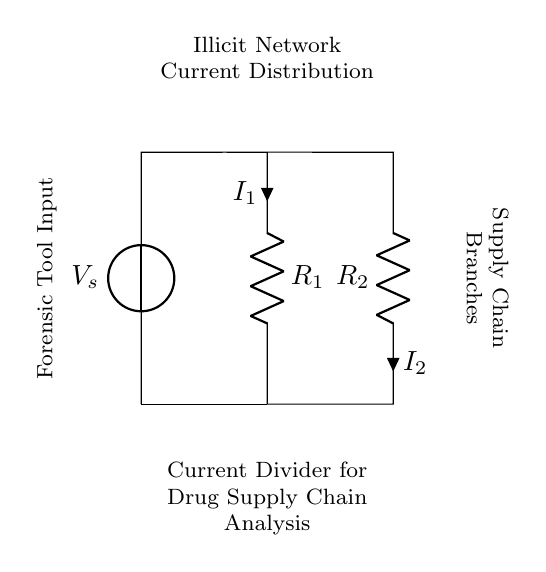What is the source voltage of this circuit? The voltage source is labeled as V_s, which represents the input voltage for the circuit, visible at the top of the circuit diagram.
Answer: V_s What are the two resistors in this current divider? The resistors in the current divider are labeled R_1 and R_2, which can be identified from the circuit as the components through which the current divides.
Answer: R_1, R_2 How many branches does the current split into? The current splits into two branches, corresponding to the two resistors in the current divider configuration. This can be determined by observing the paths the current takes through R_1 and R_2.
Answer: 2 What type of analysis does this current divider model represent? The diagram indicates that this current divider is used for drug supply chain analysis, specifically tracing illicit networks as noted at the bottom of the circuit.
Answer: Drug Supply Chain Analysis What is the current through resistor R_1 indicated as? The current through resistor R_1 is labeled as I_1, shown at the lower side of the resistor in the circuit diagram, indicating the flow of current through that branch.
Answer: I_1 Why is the connection labeled "Forensic Tool Input" important? This label highlights where the input for the forensic analysis tool is applied in the circuit, establishing the importance of how the analysis tool interfaces with the current divider to trace drug supply chains.
Answer: Important for analysis input What does the current flow direction through R_2 imply? The current flow direction through R_2 is indicated as I_2, which represents the current that branches off into that specific path, essential for understanding how the supply chain is traced through that branch.
Answer: It implies the distribution in the supply chain 